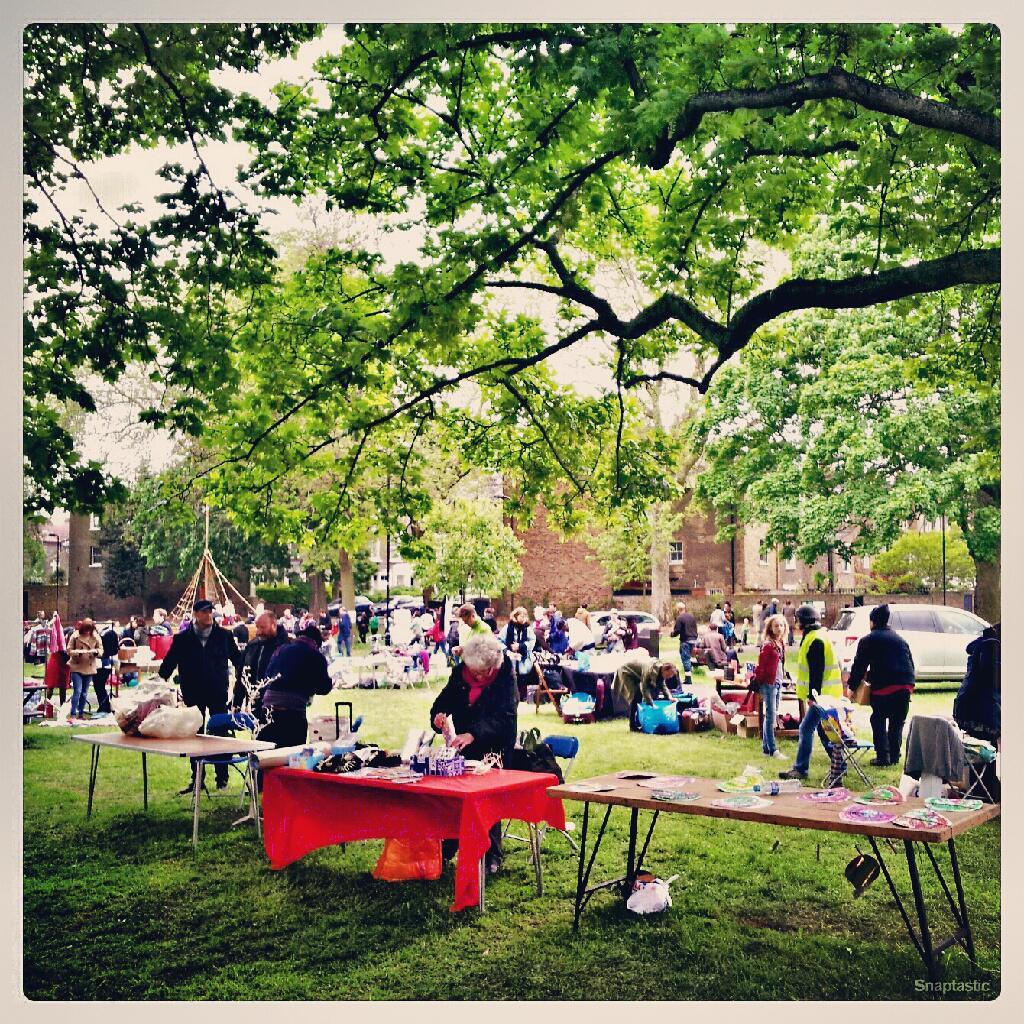Please provide a concise description of this image. In this picture we can see some persons are standing on the grass. These are the tables. On the table there is red color cloth. Here we can see a cloth. And these are the trees and there is a building. 